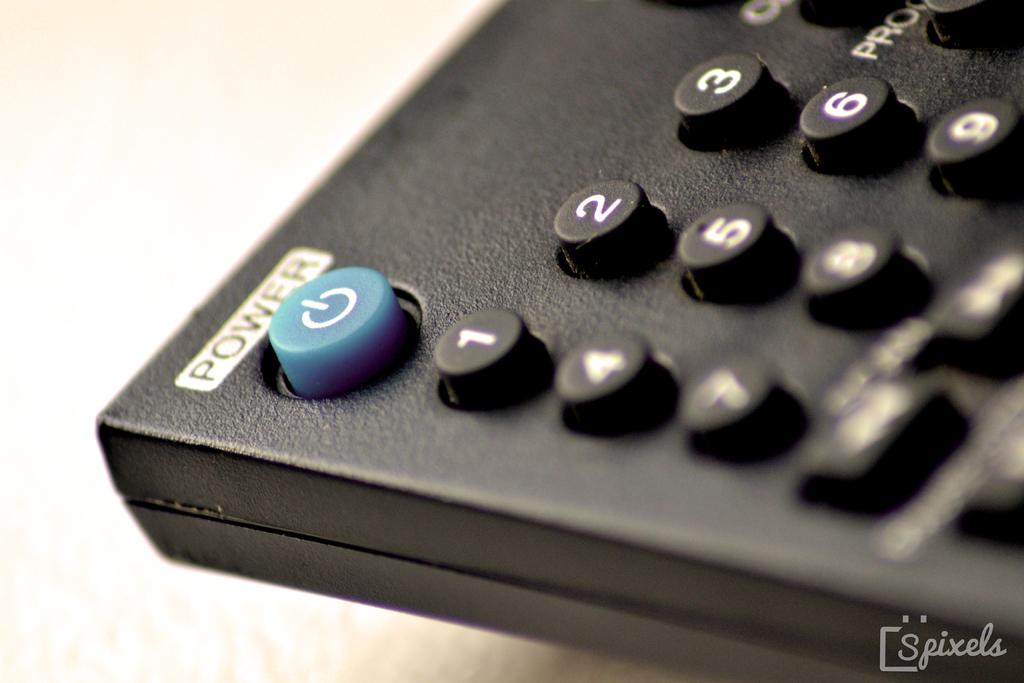What is the first number shown in the row of three keys?
Your answer should be compact. 1. 